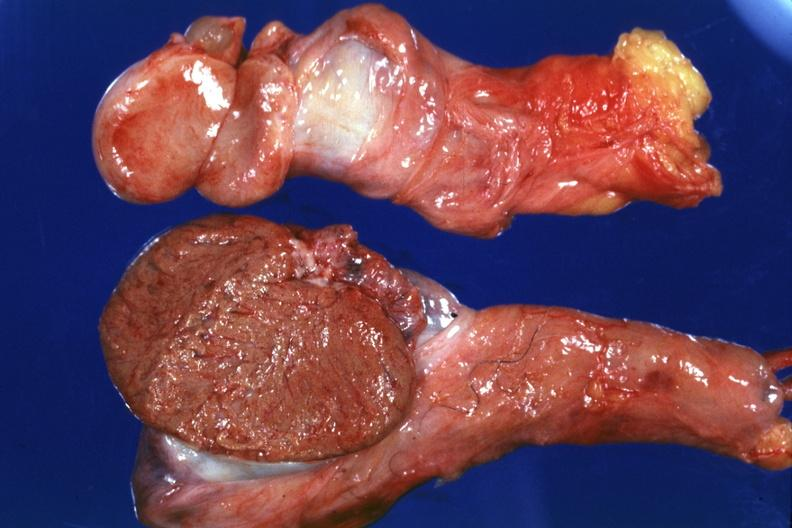what is present?
Answer the question using a single word or phrase. Fibrosis mumps 